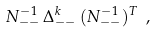Convert formula to latex. <formula><loc_0><loc_0><loc_500><loc_500>N ^ { - 1 } _ { - - } \, \Delta ^ { k } _ { - - } \, ( N ^ { - 1 } _ { - - } ) ^ { T } \ ,</formula> 